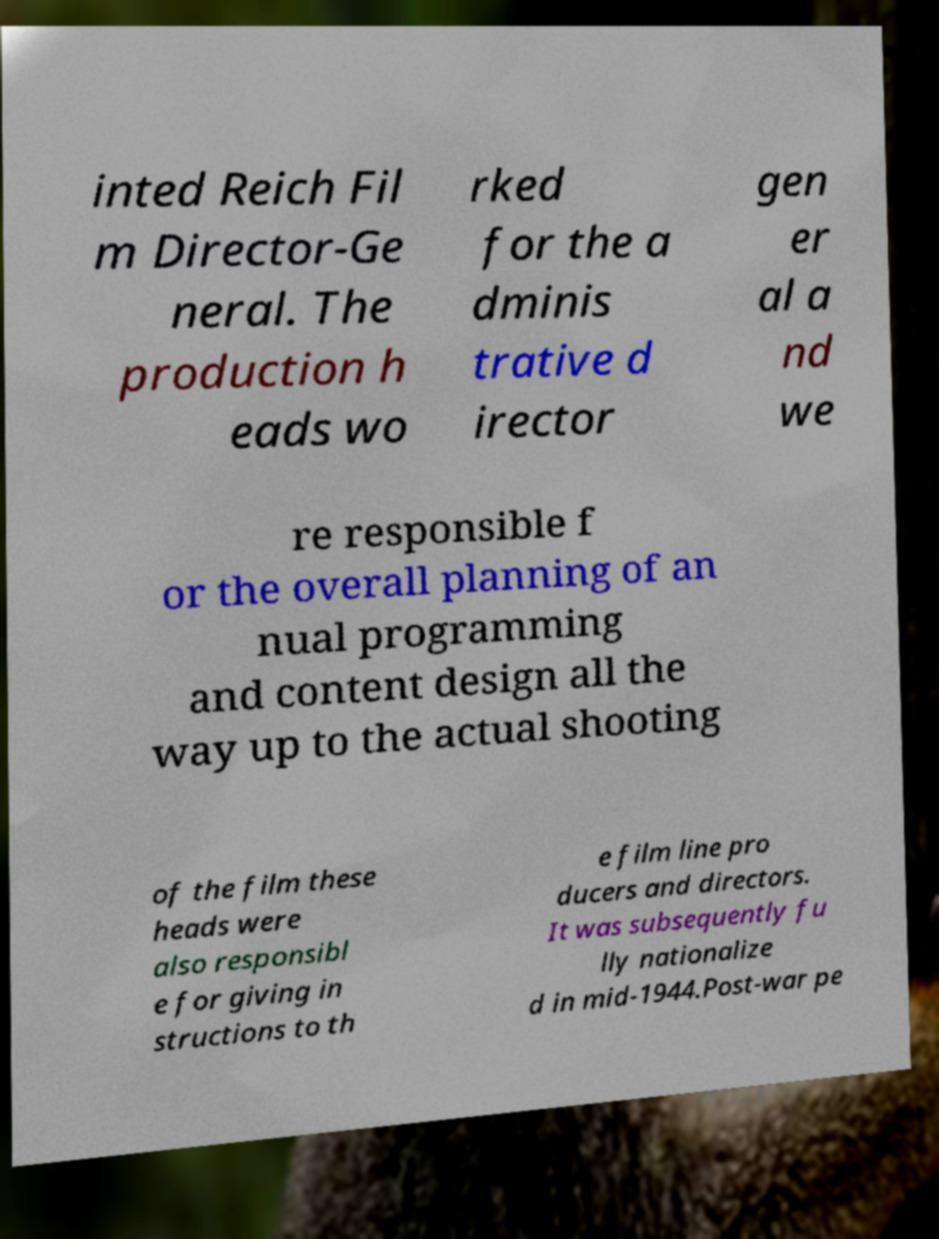Can you accurately transcribe the text from the provided image for me? inted Reich Fil m Director-Ge neral. The production h eads wo rked for the a dminis trative d irector gen er al a nd we re responsible f or the overall planning of an nual programming and content design all the way up to the actual shooting of the film these heads were also responsibl e for giving in structions to th e film line pro ducers and directors. It was subsequently fu lly nationalize d in mid-1944.Post-war pe 